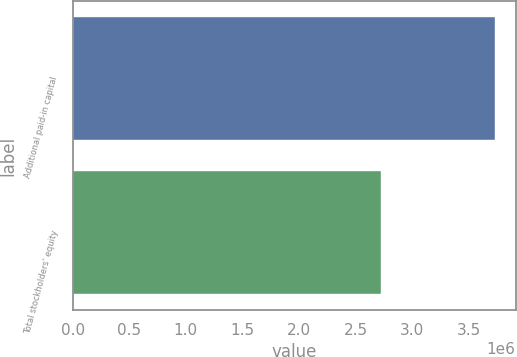<chart> <loc_0><loc_0><loc_500><loc_500><bar_chart><fcel>Additional paid-in capital<fcel>Total stockholders' equity<nl><fcel>3.72982e+06<fcel>2.72141e+06<nl></chart> 